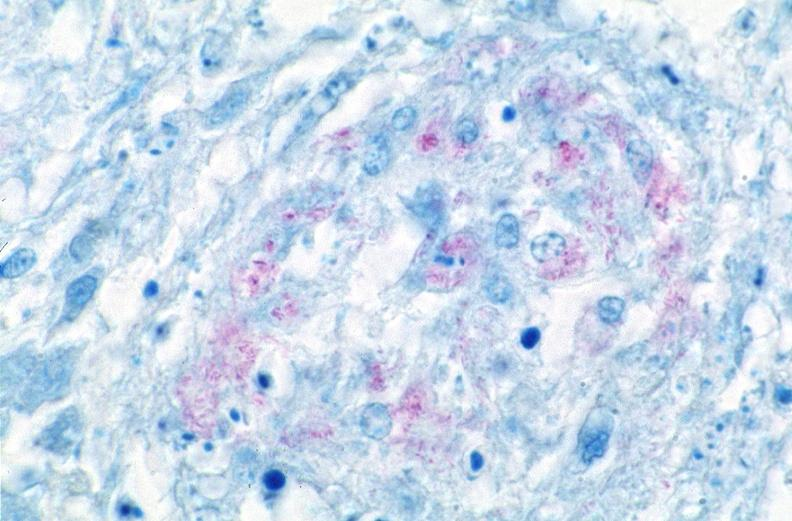does this image show lung, mycobacterium tuberculosis, acid fast?
Answer the question using a single word or phrase. Yes 